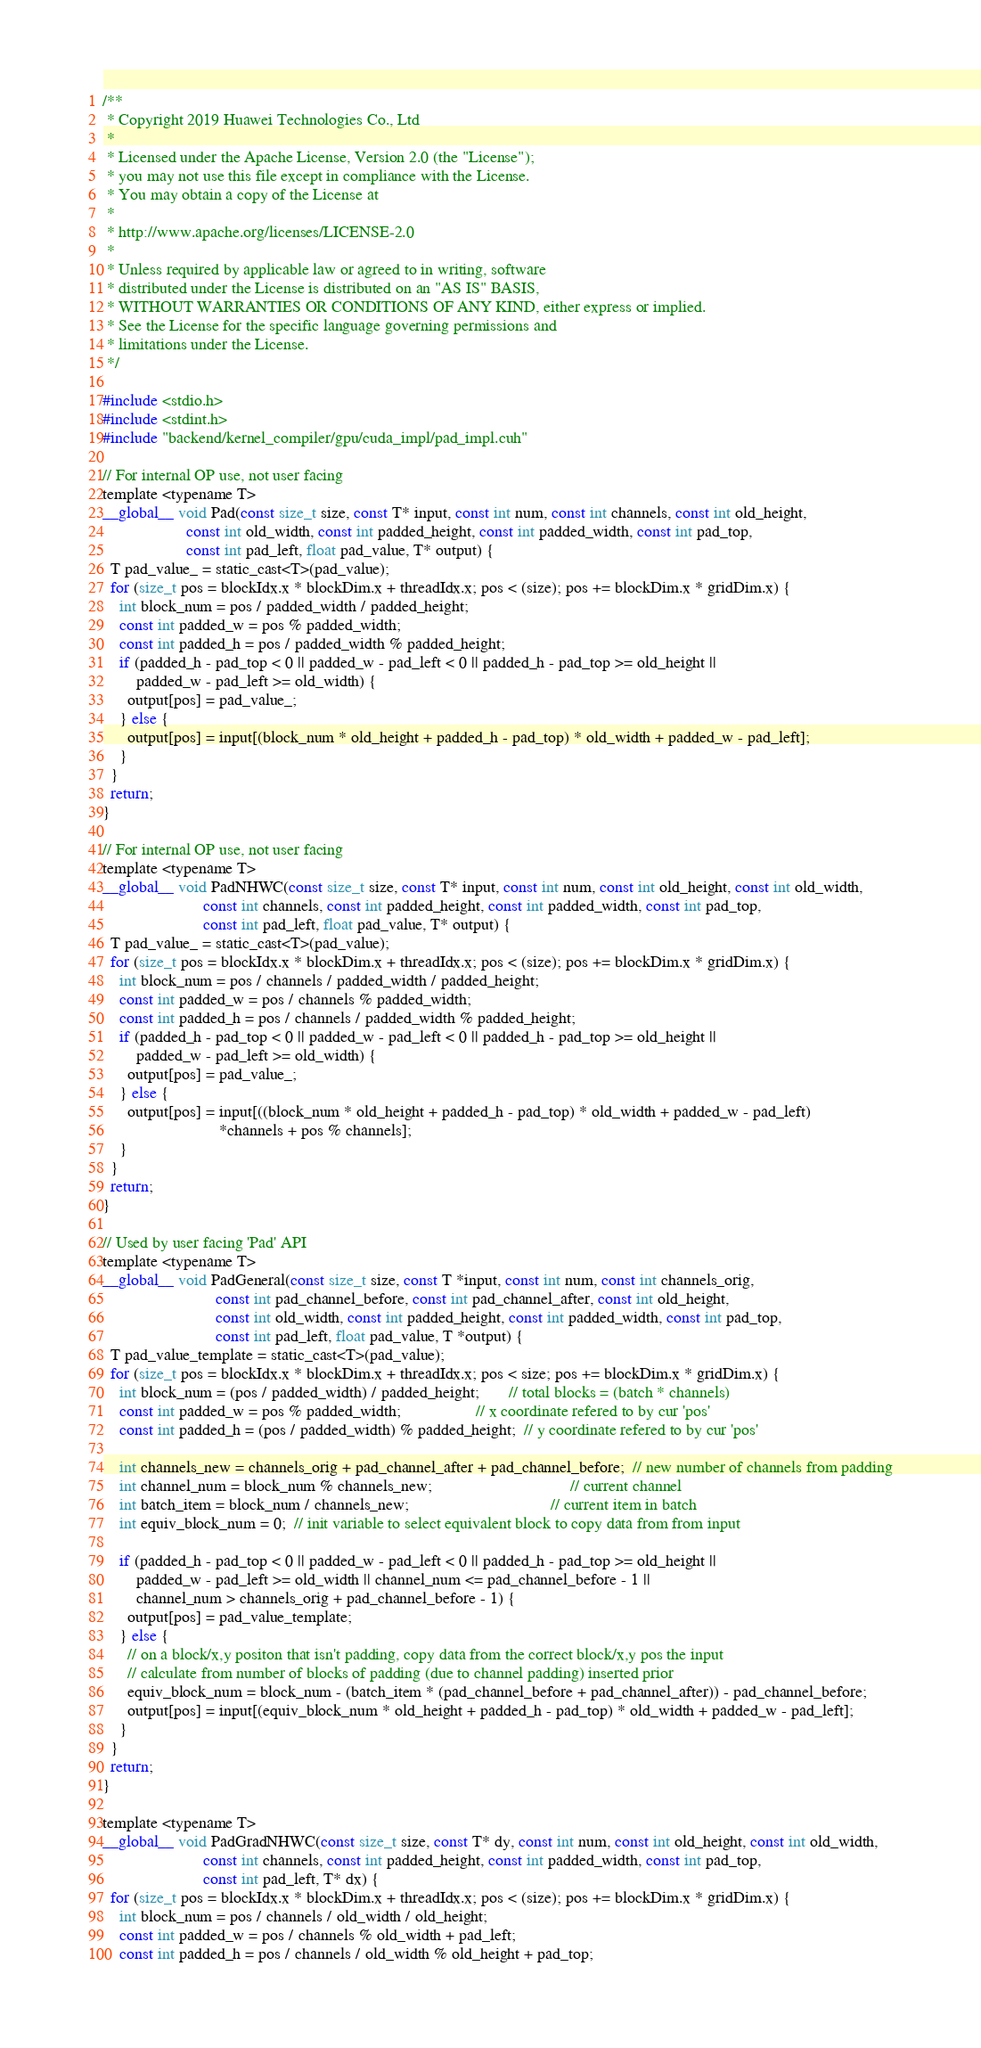<code> <loc_0><loc_0><loc_500><loc_500><_Cuda_>/**
 * Copyright 2019 Huawei Technologies Co., Ltd
 *
 * Licensed under the Apache License, Version 2.0 (the "License");
 * you may not use this file except in compliance with the License.
 * You may obtain a copy of the License at
 *
 * http://www.apache.org/licenses/LICENSE-2.0
 *
 * Unless required by applicable law or agreed to in writing, software
 * distributed under the License is distributed on an "AS IS" BASIS,
 * WITHOUT WARRANTIES OR CONDITIONS OF ANY KIND, either express or implied.
 * See the License for the specific language governing permissions and
 * limitations under the License.
 */

#include <stdio.h>
#include <stdint.h>
#include "backend/kernel_compiler/gpu/cuda_impl/pad_impl.cuh"

// For internal OP use, not user facing
template <typename T>
__global__ void Pad(const size_t size, const T* input, const int num, const int channels, const int old_height,
                    const int old_width, const int padded_height, const int padded_width, const int pad_top,
                    const int pad_left, float pad_value, T* output) {
  T pad_value_ = static_cast<T>(pad_value);
  for (size_t pos = blockIdx.x * blockDim.x + threadIdx.x; pos < (size); pos += blockDim.x * gridDim.x) {
    int block_num = pos / padded_width / padded_height;
    const int padded_w = pos % padded_width;
    const int padded_h = pos / padded_width % padded_height;
    if (padded_h - pad_top < 0 || padded_w - pad_left < 0 || padded_h - pad_top >= old_height ||
        padded_w - pad_left >= old_width) {
      output[pos] = pad_value_;
    } else {
      output[pos] = input[(block_num * old_height + padded_h - pad_top) * old_width + padded_w - pad_left];
    }
  }
  return;
}

// For internal OP use, not user facing
template <typename T>
__global__ void PadNHWC(const size_t size, const T* input, const int num, const int old_height, const int old_width,
                        const int channels, const int padded_height, const int padded_width, const int pad_top,
                        const int pad_left, float pad_value, T* output) {
  T pad_value_ = static_cast<T>(pad_value);
  for (size_t pos = blockIdx.x * blockDim.x + threadIdx.x; pos < (size); pos += blockDim.x * gridDim.x) {
    int block_num = pos / channels / padded_width / padded_height;
    const int padded_w = pos / channels % padded_width;
    const int padded_h = pos / channels / padded_width % padded_height;
    if (padded_h - pad_top < 0 || padded_w - pad_left < 0 || padded_h - pad_top >= old_height ||
        padded_w - pad_left >= old_width) {
      output[pos] = pad_value_;
    } else {
      output[pos] = input[((block_num * old_height + padded_h - pad_top) * old_width + padded_w - pad_left)
                            *channels + pos % channels];
    }
  }
  return;
}

// Used by user facing 'Pad' API
template <typename T>
__global__ void PadGeneral(const size_t size, const T *input, const int num, const int channels_orig,
                           const int pad_channel_before, const int pad_channel_after, const int old_height,
                           const int old_width, const int padded_height, const int padded_width, const int pad_top,
                           const int pad_left, float pad_value, T *output) {
  T pad_value_template = static_cast<T>(pad_value);
  for (size_t pos = blockIdx.x * blockDim.x + threadIdx.x; pos < size; pos += blockDim.x * gridDim.x) {
    int block_num = (pos / padded_width) / padded_height;       // total blocks = (batch * channels)
    const int padded_w = pos % padded_width;                  // x coordinate refered to by cur 'pos'
    const int padded_h = (pos / padded_width) % padded_height;  // y coordinate refered to by cur 'pos'

    int channels_new = channels_orig + pad_channel_after + pad_channel_before;  // new number of channels from padding
    int channel_num = block_num % channels_new;                                 // current channel
    int batch_item = block_num / channels_new;                                  // current item in batch
    int equiv_block_num = 0;  // init variable to select equivalent block to copy data from from input

    if (padded_h - pad_top < 0 || padded_w - pad_left < 0 || padded_h - pad_top >= old_height ||
        padded_w - pad_left >= old_width || channel_num <= pad_channel_before - 1 ||
        channel_num > channels_orig + pad_channel_before - 1) {
      output[pos] = pad_value_template;
    } else {
      // on a block/x,y positon that isn't padding, copy data from the correct block/x,y pos the input
      // calculate from number of blocks of padding (due to channel padding) inserted prior
      equiv_block_num = block_num - (batch_item * (pad_channel_before + pad_channel_after)) - pad_channel_before;
      output[pos] = input[(equiv_block_num * old_height + padded_h - pad_top) * old_width + padded_w - pad_left];
    }
  }
  return;
}

template <typename T>
__global__ void PadGradNHWC(const size_t size, const T* dy, const int num, const int old_height, const int old_width,
                        const int channels, const int padded_height, const int padded_width, const int pad_top,
                        const int pad_left, T* dx) {
  for (size_t pos = blockIdx.x * blockDim.x + threadIdx.x; pos < (size); pos += blockDim.x * gridDim.x) {
    int block_num = pos / channels / old_width / old_height;
    const int padded_w = pos / channels % old_width + pad_left;
    const int padded_h = pos / channels / old_width % old_height + pad_top;</code> 